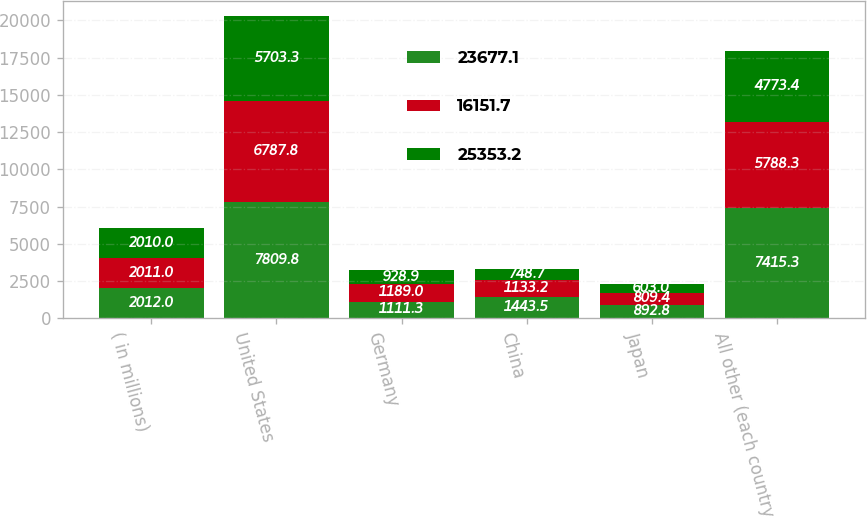<chart> <loc_0><loc_0><loc_500><loc_500><stacked_bar_chart><ecel><fcel>( in millions)<fcel>United States<fcel>Germany<fcel>China<fcel>Japan<fcel>All other (each country<nl><fcel>23677.1<fcel>2012<fcel>7809.8<fcel>1111.3<fcel>1443.5<fcel>892.8<fcel>7415.3<nl><fcel>16151.7<fcel>2011<fcel>6787.8<fcel>1189<fcel>1133.2<fcel>809.4<fcel>5788.3<nl><fcel>25353.2<fcel>2010<fcel>5703.3<fcel>928.9<fcel>748.7<fcel>603<fcel>4773.4<nl></chart> 